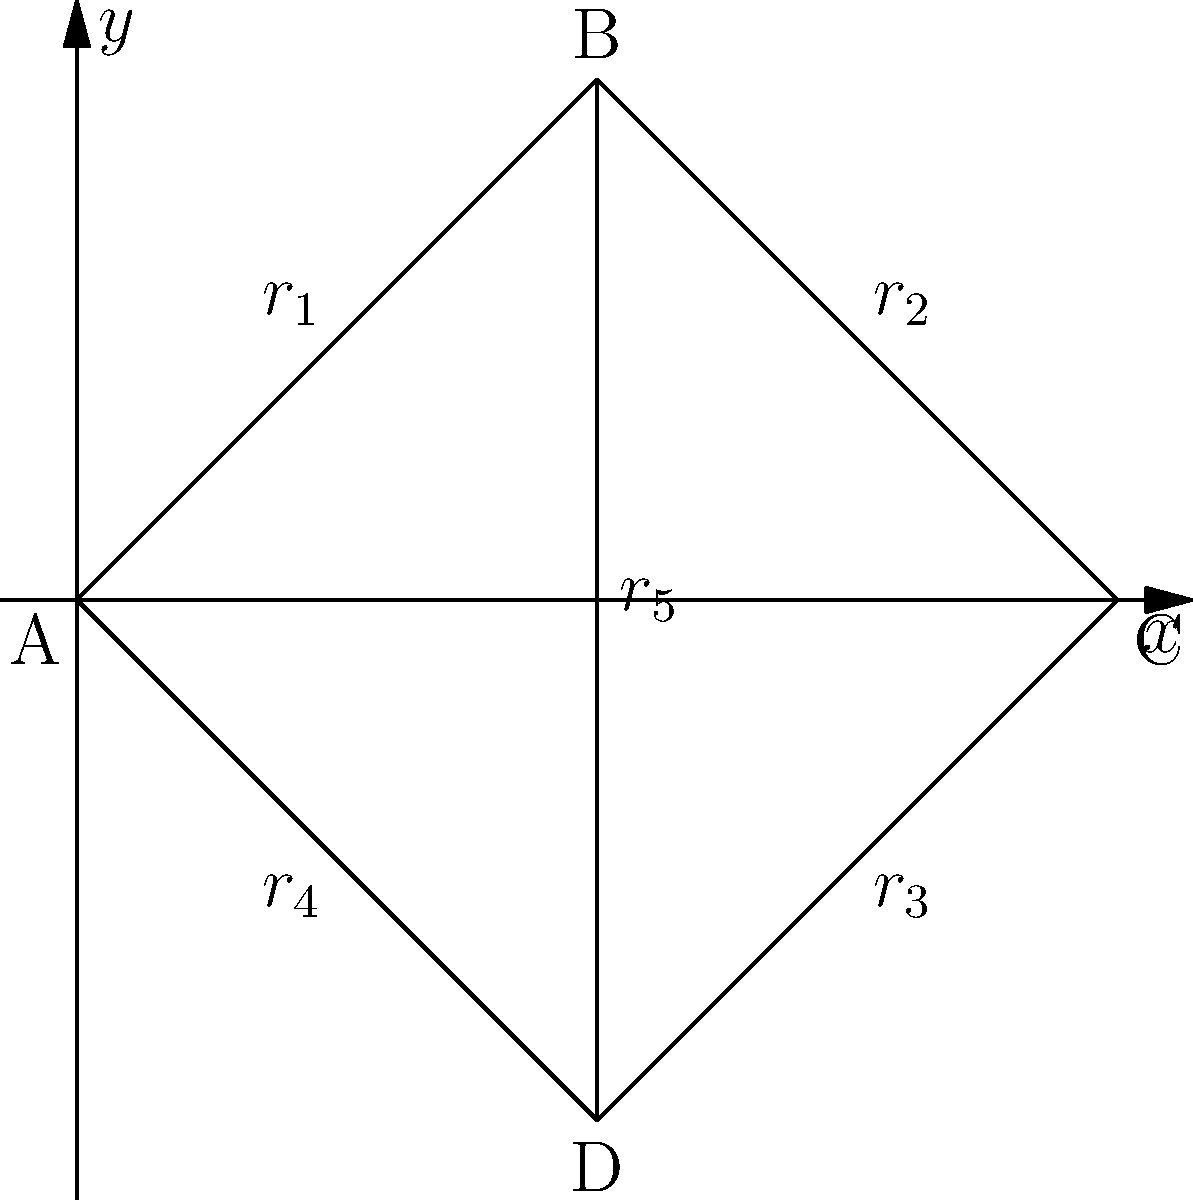In our quantum network topology, nodes A, B, C, and D represent quantum repeaters. The entanglement distribution rates between adjacent nodes are given by $r_1$, $r_2$, $r_3$, $r_4$, and $r_5$ (in pairs/second). If we want to establish end-to-end entanglement between nodes A and C, what is the maximum achievable rate $R_{AC}$ in terms of the individual rates, assuming perfect quantum operations and no decoherence? To solve this problem, we need to consider the concept of entanglement swapping and the bottleneck effect in quantum networks. The maximum end-to-end entanglement distribution rate is limited by the minimum rate along the path.

Step 1: Identify possible paths from A to C.
Path 1: A -> B -> C
Path 2: A -> D -> C
Path 3: A -> B -> D -> C

Step 2: Calculate the effective rate for each path.
For Path 1: $R_1 = \min(r_1, r_2)$
For Path 2: $R_2 = \min(r_4, r_3)$
For Path 3: $R_3 = \min(r_1, r_5, r_3)$

Step 3: The maximum achievable rate $R_{AC}$ is the sum of the rates of all possible paths:

$$R_{AC} = R_1 + R_2 + R_3$$

Step 4: Substitute the expressions from Step 2:

$$R_{AC} = \min(r_1, r_2) + \min(r_4, r_3) + \min(r_1, r_5, r_3)$$

This formula gives the maximum achievable end-to-end entanglement distribution rate between nodes A and C, considering all possible paths and accounting for the bottleneck effect in each path.
Answer: $R_{AC} = \min(r_1, r_2) + \min(r_4, r_3) + \min(r_1, r_5, r_3)$ 